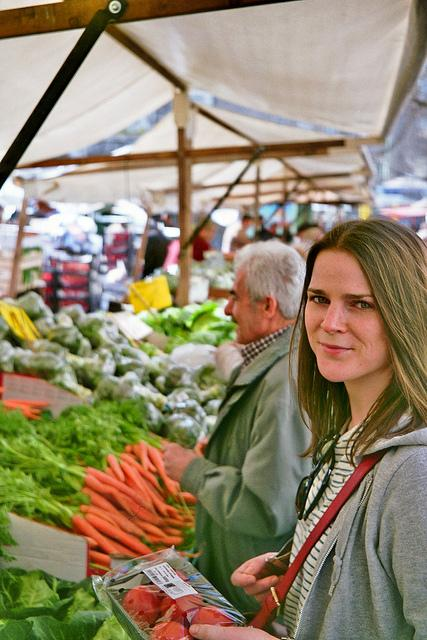Which food contains the most vitamin A?

Choices:
A) tomato
B) lettuce
C) carrot
D) broccoli carrot 